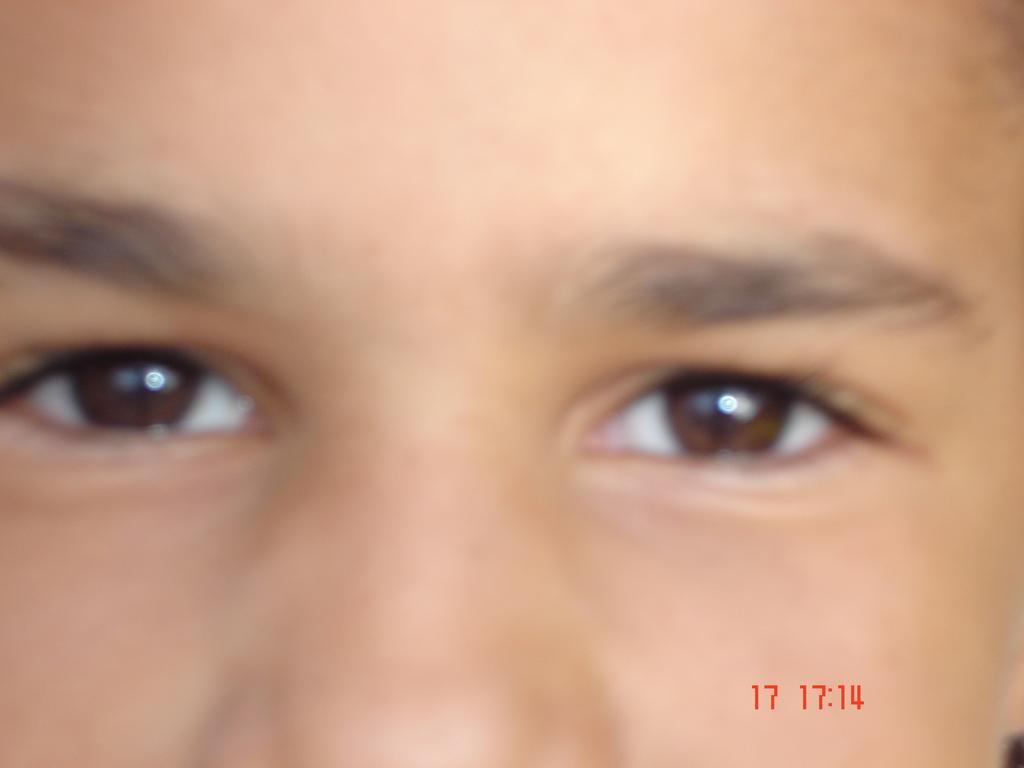In one or two sentences, can you explain what this image depicts? In this image I can see a person's eyes and nose. On the the right bottom of the image I can see few numbers in red color. 